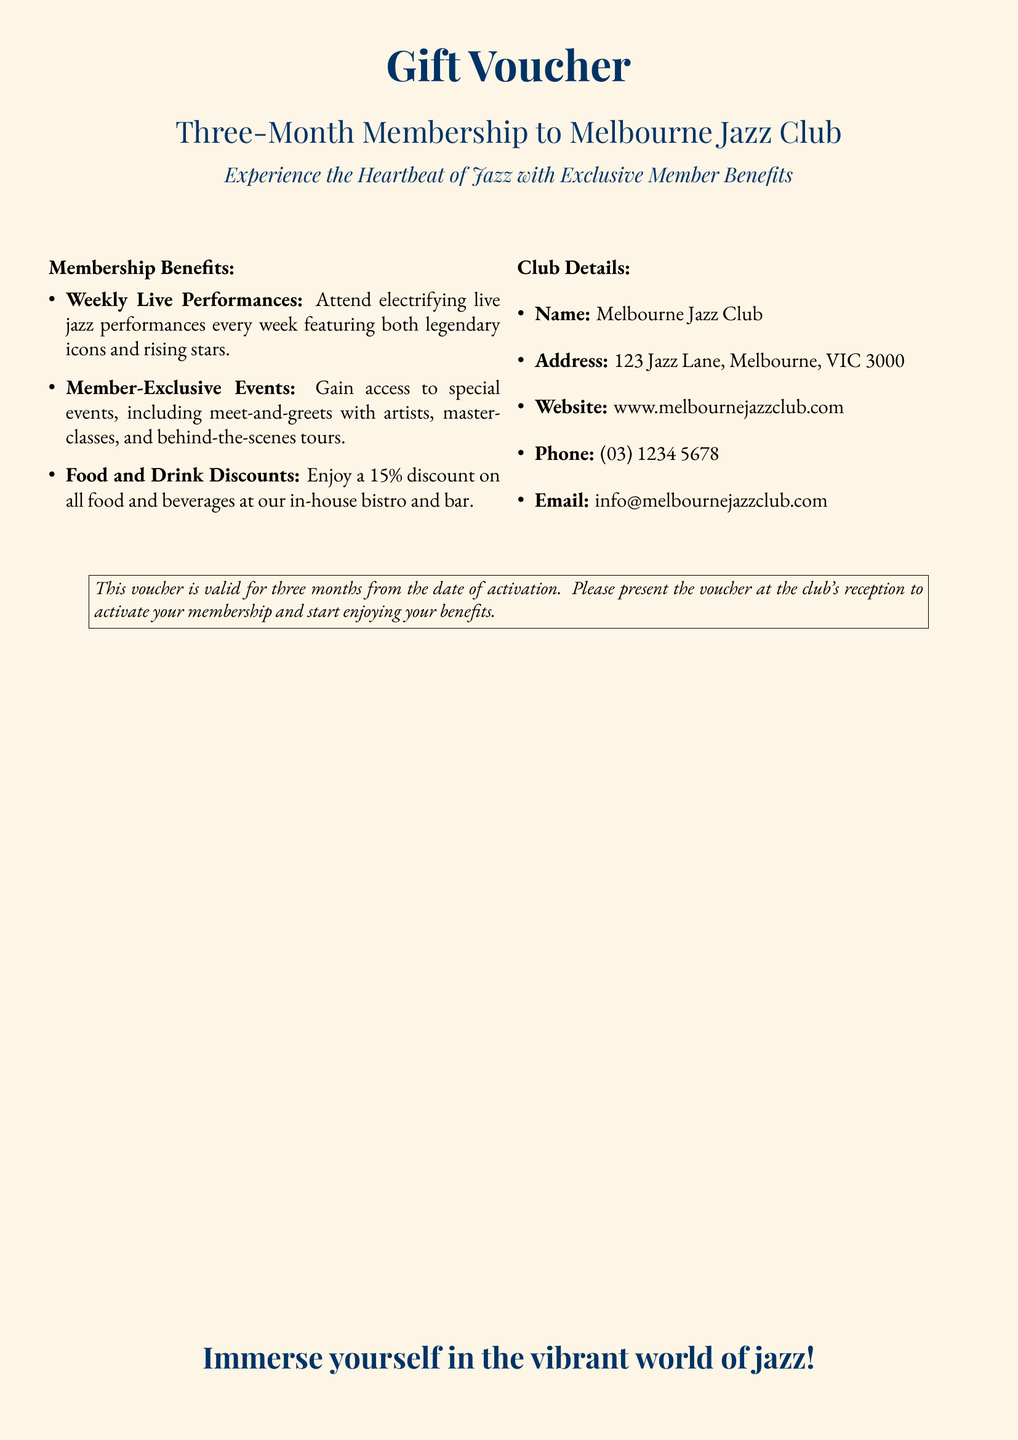What is the validity period of the voucher? The voucher is valid for three months from the date of activation as mentioned in the document.
Answer: Three months What discount do members receive on food and beverages? The document states that members enjoy a 15% discount on food and beverages.
Answer: 15% Where is the Melbourne Jazz Club located? The document provides the address as 123 Jazz Lane, Melbourne, VIC 3000.
Answer: 123 Jazz Lane, Melbourne, VIC 3000 What can members attend weekly? The document mentions that members can attend weekly live performances.
Answer: Live performances What type of events do members have access to? The document lists member-exclusive events, including meet-and-greets with artists and masterclasses.
Answer: Member-exclusive events How can the membership be activated? The document instructs to present the voucher at the club's reception to activate membership.
Answer: At the club's reception What is the website for the Melbourne Jazz Club? The document provides the website as www.melbournejazzclub.com.
Answer: www.melbournejazzclub.com What is one benefit of being a member? One of the benefits mentioned is the access to electrifying live jazz performances every week.
Answer: Access to live performances What is the purpose of this document? The document serves as a gift voucher for a three-month membership to the jazz club.
Answer: Gift voucher 